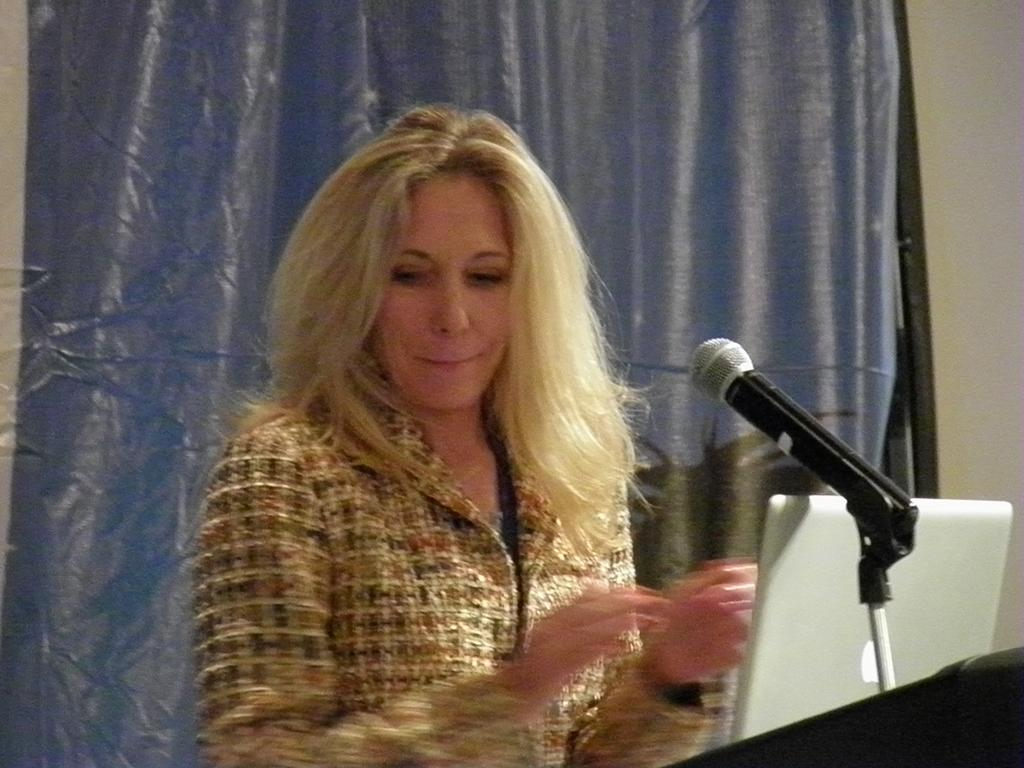Who is the main subject in the image? There is a lady in the image. What is in front of the lady? There is a mic with a mic stand in front of the lady. What electronic device is present in the image? There is a laptop in the image. What can be seen in the background of the image? There is a curtain in the background of the image. What type of soap is being used by the lady in the image? There is no soap present in the image; the lady is not shown using any soap. What kind of bottle is visible on the table in the image? There is no bottle visible in the image; only the lady, mic with a mic stand, laptop, and curtain are present. 